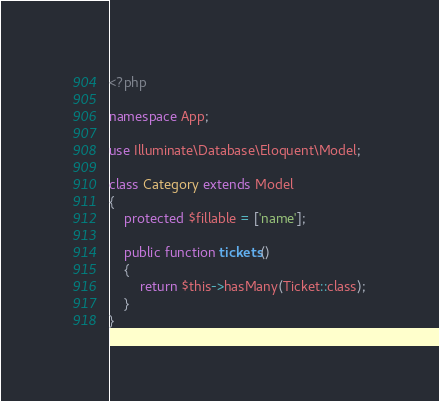Convert code to text. <code><loc_0><loc_0><loc_500><loc_500><_PHP_><?php
 
namespace App;
 
use Illuminate\Database\Eloquent\Model;
 
class Category extends Model
{
    protected $fillable = ['name'];
 
    public function tickets()
    {
        return $this->hasMany(Ticket::class);
    }
}</code> 